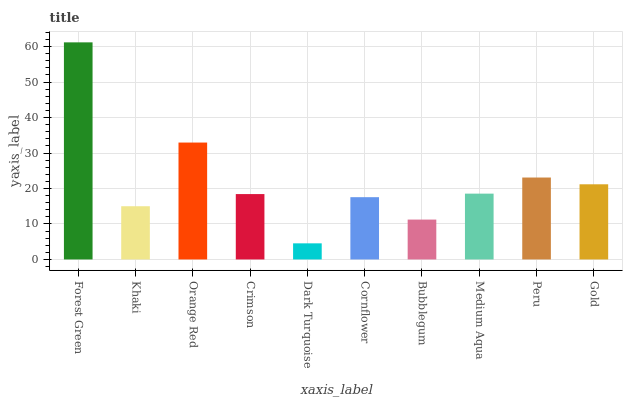Is Dark Turquoise the minimum?
Answer yes or no. Yes. Is Forest Green the maximum?
Answer yes or no. Yes. Is Khaki the minimum?
Answer yes or no. No. Is Khaki the maximum?
Answer yes or no. No. Is Forest Green greater than Khaki?
Answer yes or no. Yes. Is Khaki less than Forest Green?
Answer yes or no. Yes. Is Khaki greater than Forest Green?
Answer yes or no. No. Is Forest Green less than Khaki?
Answer yes or no. No. Is Medium Aqua the high median?
Answer yes or no. Yes. Is Crimson the low median?
Answer yes or no. Yes. Is Khaki the high median?
Answer yes or no. No. Is Medium Aqua the low median?
Answer yes or no. No. 